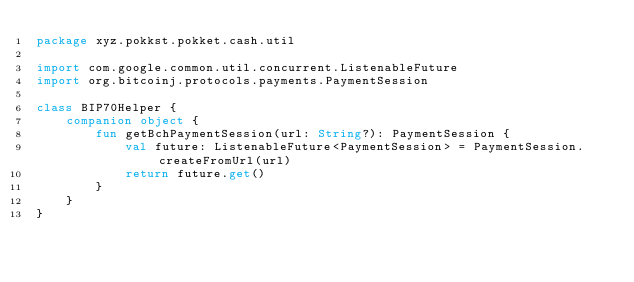<code> <loc_0><loc_0><loc_500><loc_500><_Kotlin_>package xyz.pokkst.pokket.cash.util

import com.google.common.util.concurrent.ListenableFuture
import org.bitcoinj.protocols.payments.PaymentSession

class BIP70Helper {
    companion object {
        fun getBchPaymentSession(url: String?): PaymentSession {
            val future: ListenableFuture<PaymentSession> = PaymentSession.createFromUrl(url)
            return future.get()
        }
    }
}</code> 